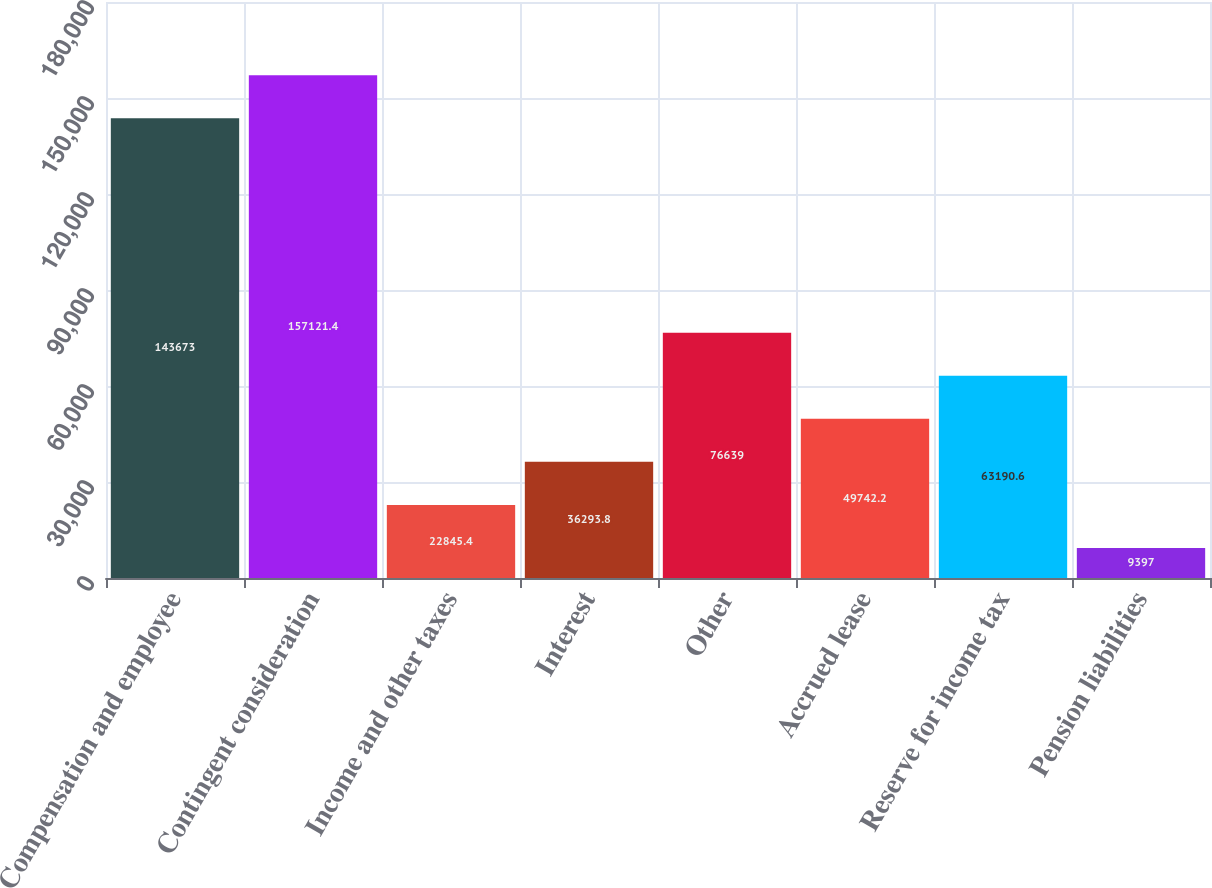<chart> <loc_0><loc_0><loc_500><loc_500><bar_chart><fcel>Compensation and employee<fcel>Contingent consideration<fcel>Income and other taxes<fcel>Interest<fcel>Other<fcel>Accrued lease<fcel>Reserve for income tax<fcel>Pension liabilities<nl><fcel>143673<fcel>157121<fcel>22845.4<fcel>36293.8<fcel>76639<fcel>49742.2<fcel>63190.6<fcel>9397<nl></chart> 